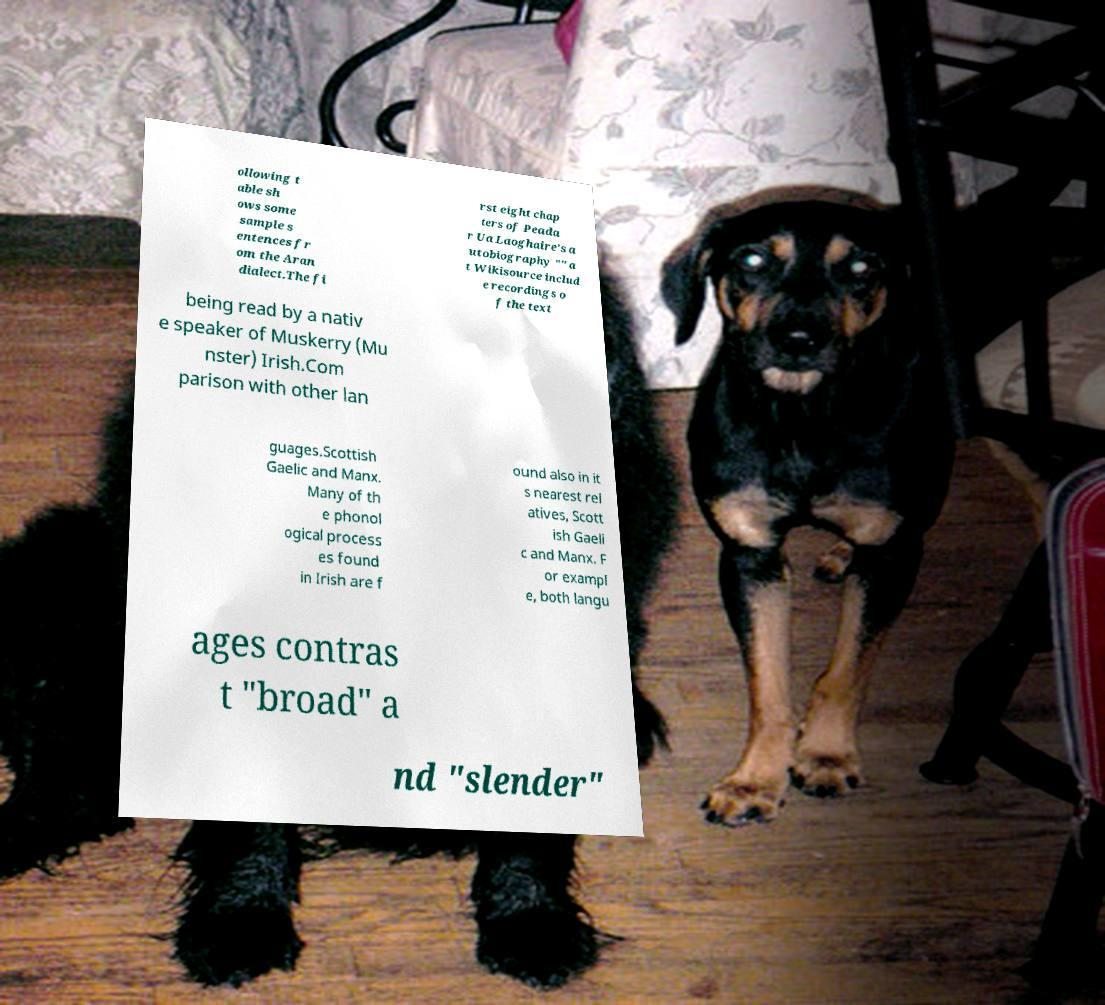Can you read and provide the text displayed in the image?This photo seems to have some interesting text. Can you extract and type it out for me? ollowing t able sh ows some sample s entences fr om the Aran dialect.The fi rst eight chap ters of Peada r Ua Laoghaire's a utobiography "" a t Wikisource includ e recordings o f the text being read by a nativ e speaker of Muskerry (Mu nster) Irish.Com parison with other lan guages.Scottish Gaelic and Manx. Many of th e phonol ogical process es found in Irish are f ound also in it s nearest rel atives, Scott ish Gaeli c and Manx. F or exampl e, both langu ages contras t "broad" a nd "slender" 